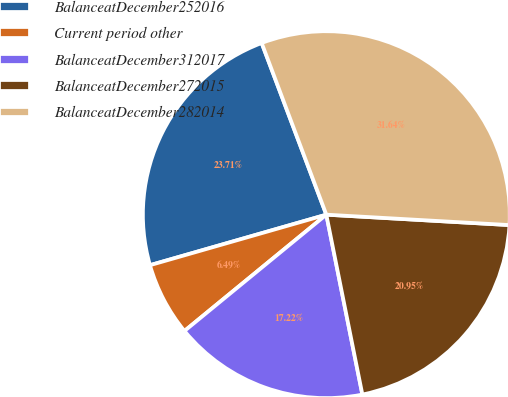Convert chart. <chart><loc_0><loc_0><loc_500><loc_500><pie_chart><fcel>BalanceatDecember252016<fcel>Current period other<fcel>BalanceatDecember312017<fcel>BalanceatDecember272015<fcel>BalanceatDecember282014<nl><fcel>23.71%<fcel>6.49%<fcel>17.22%<fcel>20.95%<fcel>31.64%<nl></chart> 